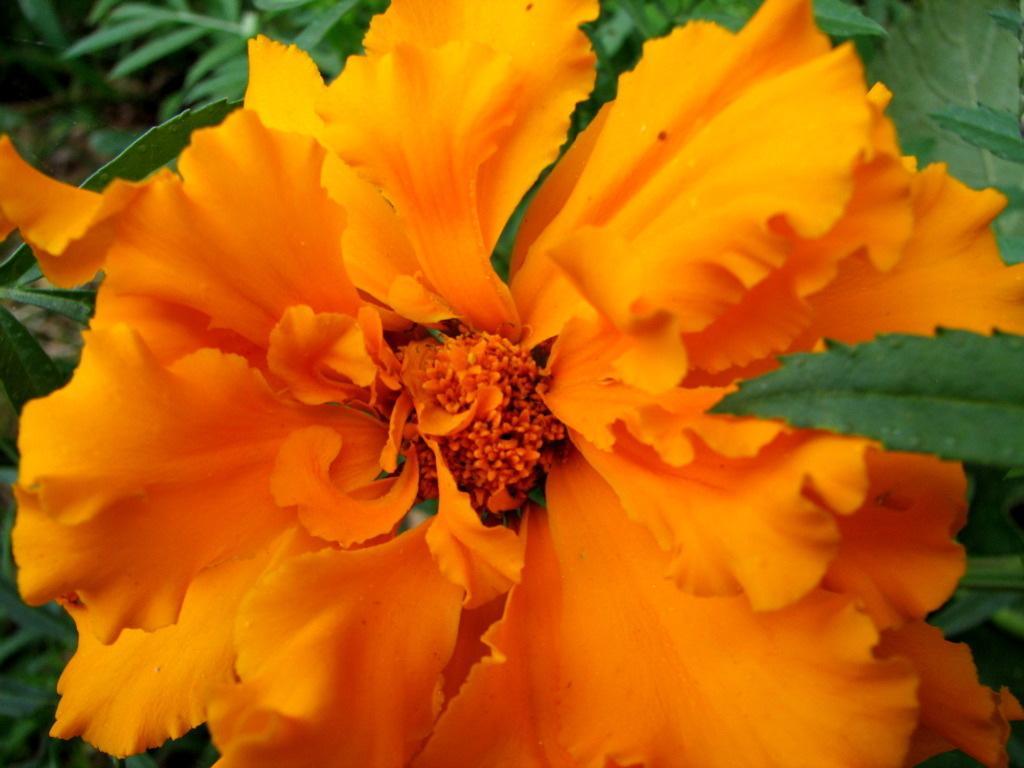Please provide a concise description of this image. In this image, we can see some leaves. There is a flower in the middle of the image. 